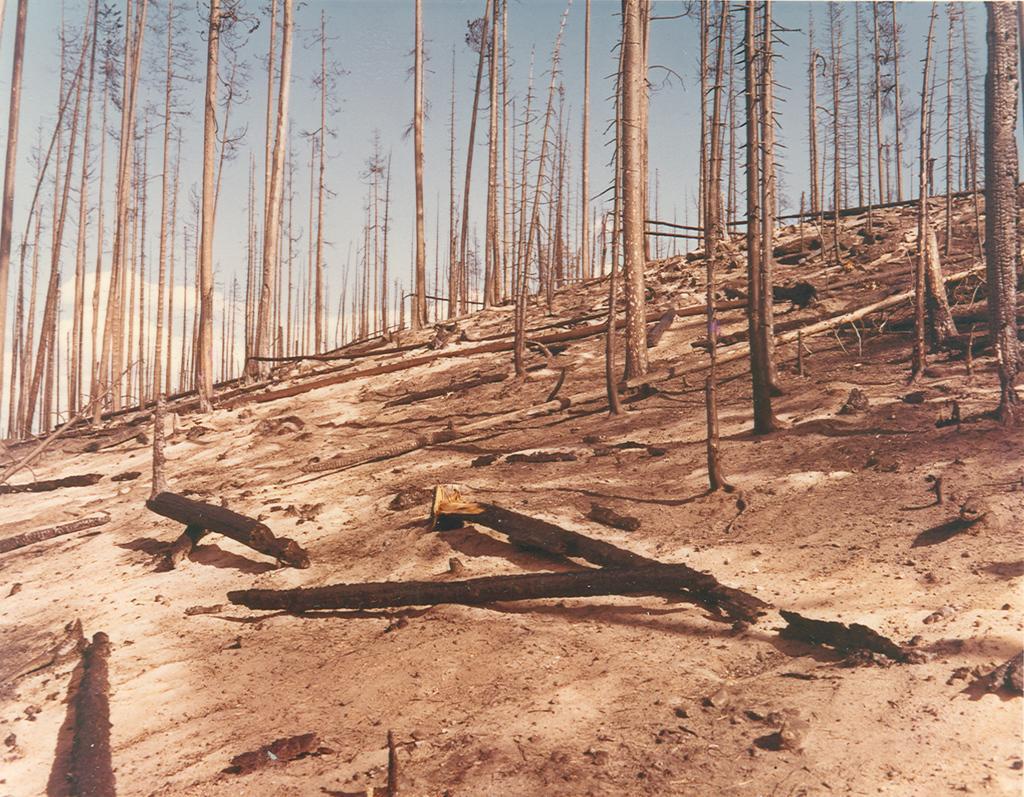Can you describe this image briefly? In this image we can see the trees on the hill. We can also see the fallen barks. In the background we can see the sky with some clouds. 